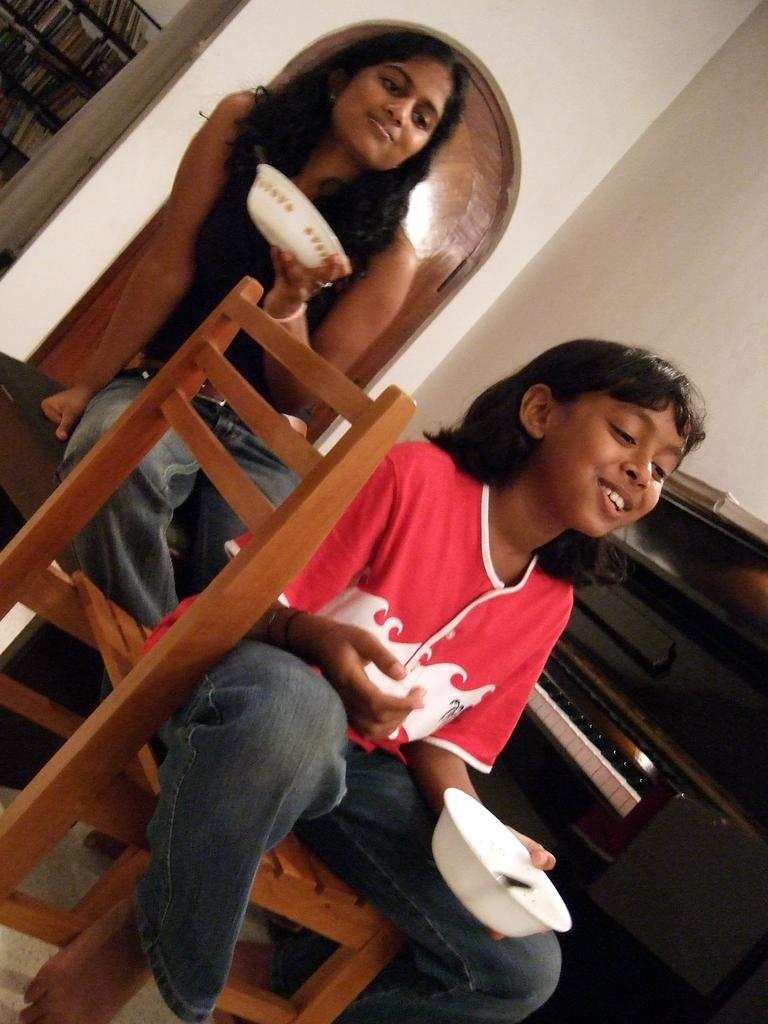How many people are in the image? There are two girls in the image. What are the girls doing in the image? The girls are sitting on chairs. What is located behind the girls in the image? The girls are sitting in front of a musical instrument. What are the girls holding in the image? The girls are holding bowls. Can you tell me which airport is visible in the image? There is no airport visible in the image; it features two girls sitting on chairs with a musical instrument behind them. What type of yarn is the girls using to play the musical instrument? There is no yarn present in the image, and the girls are not playing a musical instrument that would require yarn. 